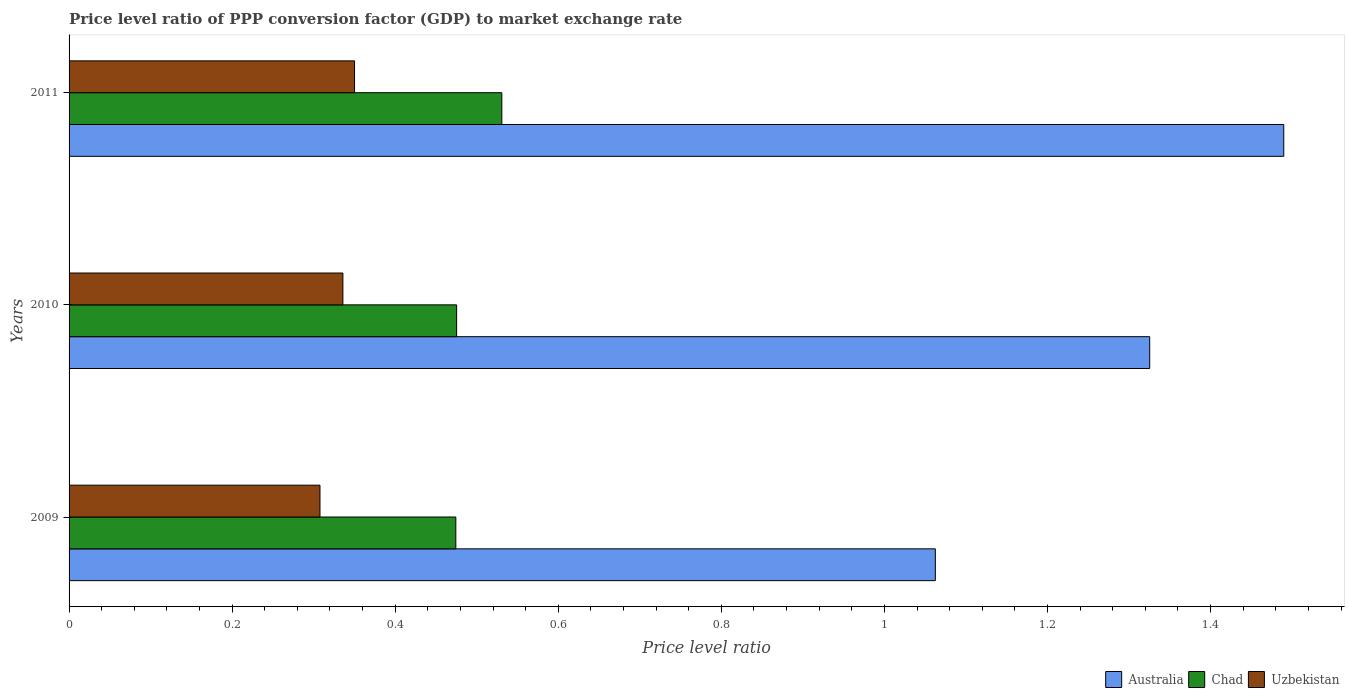How many bars are there on the 3rd tick from the top?
Your response must be concise. 3. In how many cases, is the number of bars for a given year not equal to the number of legend labels?
Ensure brevity in your answer.  0. What is the price level ratio in Chad in 2009?
Your answer should be compact. 0.47. Across all years, what is the maximum price level ratio in Uzbekistan?
Provide a succinct answer. 0.35. Across all years, what is the minimum price level ratio in Uzbekistan?
Keep it short and to the point. 0.31. In which year was the price level ratio in Uzbekistan maximum?
Your answer should be compact. 2011. In which year was the price level ratio in Australia minimum?
Provide a succinct answer. 2009. What is the total price level ratio in Australia in the graph?
Provide a succinct answer. 3.88. What is the difference between the price level ratio in Chad in 2009 and that in 2010?
Provide a short and direct response. -0. What is the difference between the price level ratio in Uzbekistan in 2010 and the price level ratio in Chad in 2009?
Ensure brevity in your answer.  -0.14. What is the average price level ratio in Uzbekistan per year?
Give a very brief answer. 0.33. In the year 2010, what is the difference between the price level ratio in Australia and price level ratio in Chad?
Make the answer very short. 0.85. What is the ratio of the price level ratio in Australia in 2009 to that in 2010?
Ensure brevity in your answer.  0.8. Is the difference between the price level ratio in Australia in 2009 and 2011 greater than the difference between the price level ratio in Chad in 2009 and 2011?
Your response must be concise. No. What is the difference between the highest and the second highest price level ratio in Uzbekistan?
Give a very brief answer. 0.01. What is the difference between the highest and the lowest price level ratio in Australia?
Offer a terse response. 0.43. In how many years, is the price level ratio in Chad greater than the average price level ratio in Chad taken over all years?
Offer a very short reply. 1. What does the 2nd bar from the bottom in 2011 represents?
Give a very brief answer. Chad. Is it the case that in every year, the sum of the price level ratio in Uzbekistan and price level ratio in Chad is greater than the price level ratio in Australia?
Give a very brief answer. No. How many bars are there?
Your answer should be compact. 9. Are all the bars in the graph horizontal?
Your answer should be compact. Yes. How many years are there in the graph?
Ensure brevity in your answer.  3. What is the difference between two consecutive major ticks on the X-axis?
Provide a succinct answer. 0.2. Are the values on the major ticks of X-axis written in scientific E-notation?
Offer a very short reply. No. What is the title of the graph?
Ensure brevity in your answer.  Price level ratio of PPP conversion factor (GDP) to market exchange rate. Does "Other small states" appear as one of the legend labels in the graph?
Your answer should be very brief. No. What is the label or title of the X-axis?
Your response must be concise. Price level ratio. What is the Price level ratio of Australia in 2009?
Ensure brevity in your answer.  1.06. What is the Price level ratio of Chad in 2009?
Your answer should be compact. 0.47. What is the Price level ratio of Uzbekistan in 2009?
Offer a very short reply. 0.31. What is the Price level ratio of Australia in 2010?
Offer a terse response. 1.33. What is the Price level ratio in Chad in 2010?
Make the answer very short. 0.48. What is the Price level ratio in Uzbekistan in 2010?
Your answer should be very brief. 0.34. What is the Price level ratio of Australia in 2011?
Give a very brief answer. 1.49. What is the Price level ratio of Chad in 2011?
Offer a very short reply. 0.53. What is the Price level ratio of Uzbekistan in 2011?
Provide a short and direct response. 0.35. Across all years, what is the maximum Price level ratio in Australia?
Give a very brief answer. 1.49. Across all years, what is the maximum Price level ratio in Chad?
Ensure brevity in your answer.  0.53. Across all years, what is the maximum Price level ratio of Uzbekistan?
Your response must be concise. 0.35. Across all years, what is the minimum Price level ratio in Australia?
Offer a very short reply. 1.06. Across all years, what is the minimum Price level ratio in Chad?
Make the answer very short. 0.47. Across all years, what is the minimum Price level ratio of Uzbekistan?
Give a very brief answer. 0.31. What is the total Price level ratio of Australia in the graph?
Provide a short and direct response. 3.88. What is the total Price level ratio in Chad in the graph?
Give a very brief answer. 1.48. What is the total Price level ratio of Uzbekistan in the graph?
Ensure brevity in your answer.  0.99. What is the difference between the Price level ratio in Australia in 2009 and that in 2010?
Ensure brevity in your answer.  -0.26. What is the difference between the Price level ratio in Chad in 2009 and that in 2010?
Keep it short and to the point. -0. What is the difference between the Price level ratio of Uzbekistan in 2009 and that in 2010?
Your answer should be very brief. -0.03. What is the difference between the Price level ratio in Australia in 2009 and that in 2011?
Keep it short and to the point. -0.43. What is the difference between the Price level ratio in Chad in 2009 and that in 2011?
Offer a very short reply. -0.06. What is the difference between the Price level ratio in Uzbekistan in 2009 and that in 2011?
Your answer should be compact. -0.04. What is the difference between the Price level ratio in Australia in 2010 and that in 2011?
Make the answer very short. -0.16. What is the difference between the Price level ratio in Chad in 2010 and that in 2011?
Give a very brief answer. -0.06. What is the difference between the Price level ratio in Uzbekistan in 2010 and that in 2011?
Your answer should be very brief. -0.01. What is the difference between the Price level ratio of Australia in 2009 and the Price level ratio of Chad in 2010?
Make the answer very short. 0.59. What is the difference between the Price level ratio in Australia in 2009 and the Price level ratio in Uzbekistan in 2010?
Your answer should be compact. 0.73. What is the difference between the Price level ratio in Chad in 2009 and the Price level ratio in Uzbekistan in 2010?
Provide a short and direct response. 0.14. What is the difference between the Price level ratio in Australia in 2009 and the Price level ratio in Chad in 2011?
Make the answer very short. 0.53. What is the difference between the Price level ratio of Australia in 2009 and the Price level ratio of Uzbekistan in 2011?
Ensure brevity in your answer.  0.71. What is the difference between the Price level ratio of Chad in 2009 and the Price level ratio of Uzbekistan in 2011?
Offer a terse response. 0.12. What is the difference between the Price level ratio in Australia in 2010 and the Price level ratio in Chad in 2011?
Provide a short and direct response. 0.79. What is the difference between the Price level ratio of Australia in 2010 and the Price level ratio of Uzbekistan in 2011?
Make the answer very short. 0.98. What is the difference between the Price level ratio of Chad in 2010 and the Price level ratio of Uzbekistan in 2011?
Offer a terse response. 0.13. What is the average Price level ratio of Australia per year?
Your answer should be very brief. 1.29. What is the average Price level ratio in Chad per year?
Your answer should be very brief. 0.49. What is the average Price level ratio of Uzbekistan per year?
Offer a very short reply. 0.33. In the year 2009, what is the difference between the Price level ratio in Australia and Price level ratio in Chad?
Offer a terse response. 0.59. In the year 2009, what is the difference between the Price level ratio in Australia and Price level ratio in Uzbekistan?
Keep it short and to the point. 0.75. In the year 2009, what is the difference between the Price level ratio of Chad and Price level ratio of Uzbekistan?
Offer a terse response. 0.17. In the year 2010, what is the difference between the Price level ratio of Australia and Price level ratio of Chad?
Keep it short and to the point. 0.85. In the year 2010, what is the difference between the Price level ratio of Chad and Price level ratio of Uzbekistan?
Make the answer very short. 0.14. In the year 2011, what is the difference between the Price level ratio of Australia and Price level ratio of Chad?
Your answer should be compact. 0.96. In the year 2011, what is the difference between the Price level ratio of Australia and Price level ratio of Uzbekistan?
Your answer should be very brief. 1.14. In the year 2011, what is the difference between the Price level ratio in Chad and Price level ratio in Uzbekistan?
Provide a succinct answer. 0.18. What is the ratio of the Price level ratio of Australia in 2009 to that in 2010?
Give a very brief answer. 0.8. What is the ratio of the Price level ratio of Uzbekistan in 2009 to that in 2010?
Keep it short and to the point. 0.92. What is the ratio of the Price level ratio in Australia in 2009 to that in 2011?
Keep it short and to the point. 0.71. What is the ratio of the Price level ratio of Chad in 2009 to that in 2011?
Provide a succinct answer. 0.89. What is the ratio of the Price level ratio in Uzbekistan in 2009 to that in 2011?
Offer a very short reply. 0.88. What is the ratio of the Price level ratio in Australia in 2010 to that in 2011?
Give a very brief answer. 0.89. What is the ratio of the Price level ratio of Chad in 2010 to that in 2011?
Provide a succinct answer. 0.9. What is the ratio of the Price level ratio in Uzbekistan in 2010 to that in 2011?
Provide a short and direct response. 0.96. What is the difference between the highest and the second highest Price level ratio in Australia?
Ensure brevity in your answer.  0.16. What is the difference between the highest and the second highest Price level ratio in Chad?
Provide a short and direct response. 0.06. What is the difference between the highest and the second highest Price level ratio in Uzbekistan?
Keep it short and to the point. 0.01. What is the difference between the highest and the lowest Price level ratio of Australia?
Make the answer very short. 0.43. What is the difference between the highest and the lowest Price level ratio of Chad?
Offer a terse response. 0.06. What is the difference between the highest and the lowest Price level ratio in Uzbekistan?
Your answer should be very brief. 0.04. 